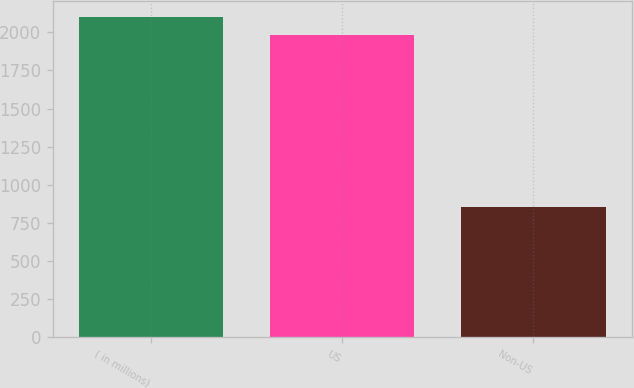<chart> <loc_0><loc_0><loc_500><loc_500><bar_chart><fcel>( in millions)<fcel>US<fcel>Non-US<nl><fcel>2099.4<fcel>1983<fcel>853<nl></chart> 